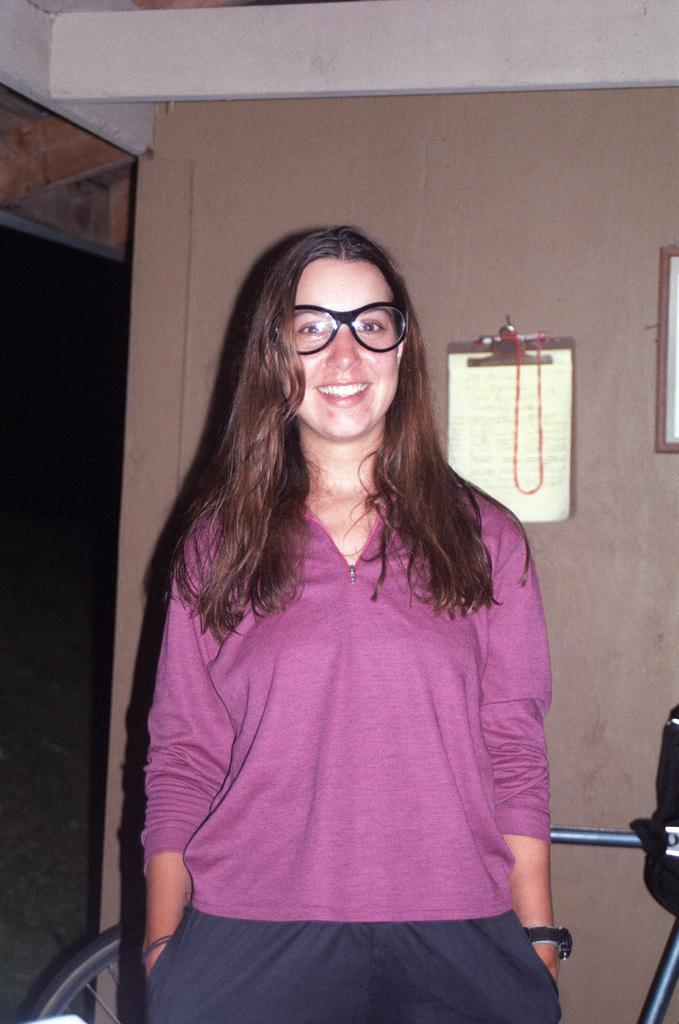Who is present in the image? There is a woman in the image. What can be observed about the woman's appearance? The woman is wearing spectacles and has a smile on her face. What is on the wall in the image? There are examination pads with papers on the wall. What object can be seen in the image that is typically used for transportation? There is a bicycle visible in the image. What type of blade is being sharpened by the woman in the image? There is no blade present in the image, and the woman is not shown sharpening anything. 